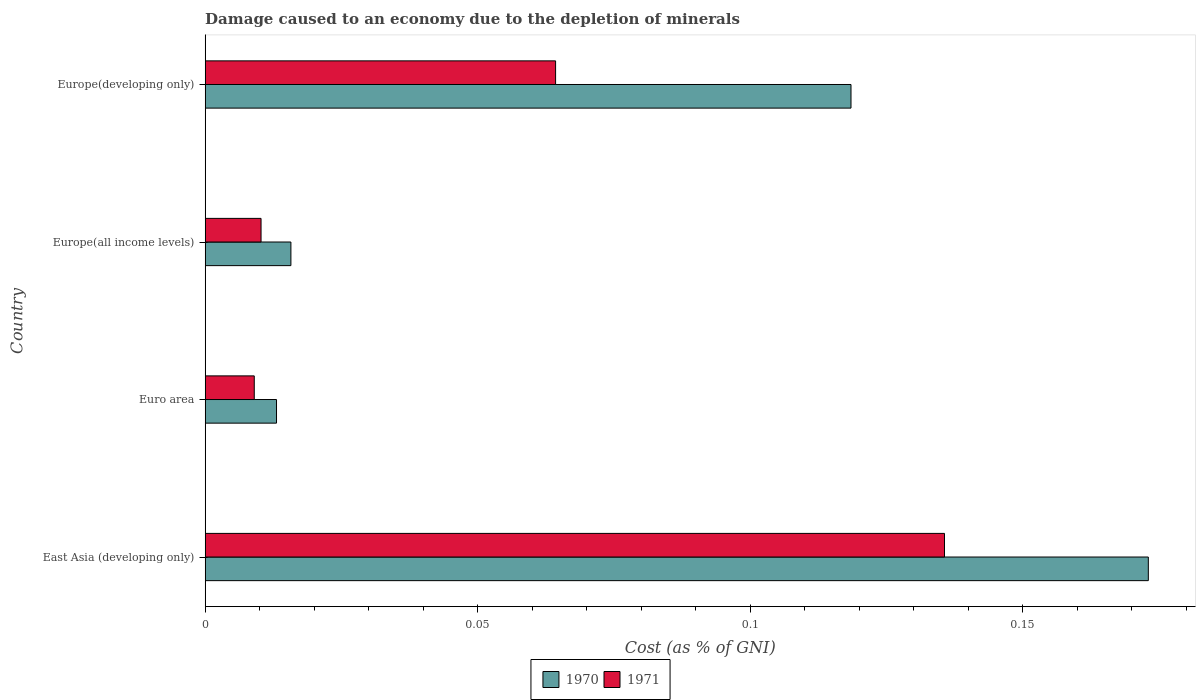How many different coloured bars are there?
Offer a very short reply. 2. How many groups of bars are there?
Offer a very short reply. 4. Are the number of bars per tick equal to the number of legend labels?
Keep it short and to the point. Yes. How many bars are there on the 2nd tick from the bottom?
Your answer should be compact. 2. What is the label of the 4th group of bars from the top?
Provide a short and direct response. East Asia (developing only). In how many cases, is the number of bars for a given country not equal to the number of legend labels?
Your answer should be very brief. 0. What is the cost of damage caused due to the depletion of minerals in 1971 in East Asia (developing only)?
Offer a very short reply. 0.14. Across all countries, what is the maximum cost of damage caused due to the depletion of minerals in 1971?
Keep it short and to the point. 0.14. Across all countries, what is the minimum cost of damage caused due to the depletion of minerals in 1971?
Provide a succinct answer. 0.01. In which country was the cost of damage caused due to the depletion of minerals in 1970 maximum?
Make the answer very short. East Asia (developing only). What is the total cost of damage caused due to the depletion of minerals in 1970 in the graph?
Keep it short and to the point. 0.32. What is the difference between the cost of damage caused due to the depletion of minerals in 1970 in Euro area and that in Europe(developing only)?
Make the answer very short. -0.11. What is the difference between the cost of damage caused due to the depletion of minerals in 1970 in East Asia (developing only) and the cost of damage caused due to the depletion of minerals in 1971 in Europe(all income levels)?
Provide a short and direct response. 0.16. What is the average cost of damage caused due to the depletion of minerals in 1971 per country?
Your answer should be compact. 0.05. What is the difference between the cost of damage caused due to the depletion of minerals in 1970 and cost of damage caused due to the depletion of minerals in 1971 in Euro area?
Your answer should be very brief. 0. In how many countries, is the cost of damage caused due to the depletion of minerals in 1971 greater than 0.16000000000000003 %?
Provide a succinct answer. 0. What is the ratio of the cost of damage caused due to the depletion of minerals in 1971 in East Asia (developing only) to that in Europe(all income levels)?
Give a very brief answer. 13.24. Is the cost of damage caused due to the depletion of minerals in 1971 in Europe(all income levels) less than that in Europe(developing only)?
Keep it short and to the point. Yes. What is the difference between the highest and the second highest cost of damage caused due to the depletion of minerals in 1970?
Ensure brevity in your answer.  0.05. What is the difference between the highest and the lowest cost of damage caused due to the depletion of minerals in 1971?
Provide a short and direct response. 0.13. In how many countries, is the cost of damage caused due to the depletion of minerals in 1970 greater than the average cost of damage caused due to the depletion of minerals in 1970 taken over all countries?
Give a very brief answer. 2. What does the 1st bar from the top in Euro area represents?
Provide a short and direct response. 1971. What does the 2nd bar from the bottom in East Asia (developing only) represents?
Offer a terse response. 1971. How many bars are there?
Ensure brevity in your answer.  8. Are all the bars in the graph horizontal?
Keep it short and to the point. Yes. Does the graph contain grids?
Provide a short and direct response. No. Where does the legend appear in the graph?
Your answer should be very brief. Bottom center. What is the title of the graph?
Keep it short and to the point. Damage caused to an economy due to the depletion of minerals. Does "2005" appear as one of the legend labels in the graph?
Offer a terse response. No. What is the label or title of the X-axis?
Offer a very short reply. Cost (as % of GNI). What is the label or title of the Y-axis?
Offer a very short reply. Country. What is the Cost (as % of GNI) in 1970 in East Asia (developing only)?
Your answer should be very brief. 0.17. What is the Cost (as % of GNI) of 1971 in East Asia (developing only)?
Keep it short and to the point. 0.14. What is the Cost (as % of GNI) of 1970 in Euro area?
Provide a succinct answer. 0.01. What is the Cost (as % of GNI) in 1971 in Euro area?
Provide a succinct answer. 0.01. What is the Cost (as % of GNI) of 1970 in Europe(all income levels)?
Your answer should be compact. 0.02. What is the Cost (as % of GNI) of 1971 in Europe(all income levels)?
Provide a succinct answer. 0.01. What is the Cost (as % of GNI) of 1970 in Europe(developing only)?
Your answer should be compact. 0.12. What is the Cost (as % of GNI) in 1971 in Europe(developing only)?
Make the answer very short. 0.06. Across all countries, what is the maximum Cost (as % of GNI) in 1970?
Provide a short and direct response. 0.17. Across all countries, what is the maximum Cost (as % of GNI) of 1971?
Make the answer very short. 0.14. Across all countries, what is the minimum Cost (as % of GNI) of 1970?
Your answer should be compact. 0.01. Across all countries, what is the minimum Cost (as % of GNI) in 1971?
Your answer should be very brief. 0.01. What is the total Cost (as % of GNI) of 1970 in the graph?
Provide a short and direct response. 0.32. What is the total Cost (as % of GNI) in 1971 in the graph?
Offer a terse response. 0.22. What is the difference between the Cost (as % of GNI) in 1970 in East Asia (developing only) and that in Euro area?
Offer a very short reply. 0.16. What is the difference between the Cost (as % of GNI) in 1971 in East Asia (developing only) and that in Euro area?
Make the answer very short. 0.13. What is the difference between the Cost (as % of GNI) of 1970 in East Asia (developing only) and that in Europe(all income levels)?
Make the answer very short. 0.16. What is the difference between the Cost (as % of GNI) of 1971 in East Asia (developing only) and that in Europe(all income levels)?
Provide a short and direct response. 0.13. What is the difference between the Cost (as % of GNI) in 1970 in East Asia (developing only) and that in Europe(developing only)?
Ensure brevity in your answer.  0.05. What is the difference between the Cost (as % of GNI) in 1971 in East Asia (developing only) and that in Europe(developing only)?
Your answer should be very brief. 0.07. What is the difference between the Cost (as % of GNI) of 1970 in Euro area and that in Europe(all income levels)?
Give a very brief answer. -0. What is the difference between the Cost (as % of GNI) in 1971 in Euro area and that in Europe(all income levels)?
Ensure brevity in your answer.  -0. What is the difference between the Cost (as % of GNI) of 1970 in Euro area and that in Europe(developing only)?
Make the answer very short. -0.11. What is the difference between the Cost (as % of GNI) in 1971 in Euro area and that in Europe(developing only)?
Give a very brief answer. -0.06. What is the difference between the Cost (as % of GNI) of 1970 in Europe(all income levels) and that in Europe(developing only)?
Make the answer very short. -0.1. What is the difference between the Cost (as % of GNI) of 1971 in Europe(all income levels) and that in Europe(developing only)?
Ensure brevity in your answer.  -0.05. What is the difference between the Cost (as % of GNI) in 1970 in East Asia (developing only) and the Cost (as % of GNI) in 1971 in Euro area?
Your answer should be compact. 0.16. What is the difference between the Cost (as % of GNI) of 1970 in East Asia (developing only) and the Cost (as % of GNI) of 1971 in Europe(all income levels)?
Give a very brief answer. 0.16. What is the difference between the Cost (as % of GNI) of 1970 in East Asia (developing only) and the Cost (as % of GNI) of 1971 in Europe(developing only)?
Provide a short and direct response. 0.11. What is the difference between the Cost (as % of GNI) of 1970 in Euro area and the Cost (as % of GNI) of 1971 in Europe(all income levels)?
Provide a succinct answer. 0. What is the difference between the Cost (as % of GNI) in 1970 in Euro area and the Cost (as % of GNI) in 1971 in Europe(developing only)?
Offer a very short reply. -0.05. What is the difference between the Cost (as % of GNI) in 1970 in Europe(all income levels) and the Cost (as % of GNI) in 1971 in Europe(developing only)?
Make the answer very short. -0.05. What is the average Cost (as % of GNI) of 1970 per country?
Your answer should be very brief. 0.08. What is the average Cost (as % of GNI) in 1971 per country?
Offer a terse response. 0.05. What is the difference between the Cost (as % of GNI) of 1970 and Cost (as % of GNI) of 1971 in East Asia (developing only)?
Provide a short and direct response. 0.04. What is the difference between the Cost (as % of GNI) of 1970 and Cost (as % of GNI) of 1971 in Euro area?
Offer a very short reply. 0. What is the difference between the Cost (as % of GNI) of 1970 and Cost (as % of GNI) of 1971 in Europe(all income levels)?
Ensure brevity in your answer.  0.01. What is the difference between the Cost (as % of GNI) in 1970 and Cost (as % of GNI) in 1971 in Europe(developing only)?
Provide a short and direct response. 0.05. What is the ratio of the Cost (as % of GNI) in 1970 in East Asia (developing only) to that in Euro area?
Provide a short and direct response. 13.22. What is the ratio of the Cost (as % of GNI) in 1971 in East Asia (developing only) to that in Euro area?
Your answer should be compact. 15.07. What is the ratio of the Cost (as % of GNI) of 1970 in East Asia (developing only) to that in Europe(all income levels)?
Your response must be concise. 11. What is the ratio of the Cost (as % of GNI) of 1971 in East Asia (developing only) to that in Europe(all income levels)?
Your answer should be compact. 13.24. What is the ratio of the Cost (as % of GNI) in 1970 in East Asia (developing only) to that in Europe(developing only)?
Make the answer very short. 1.46. What is the ratio of the Cost (as % of GNI) of 1971 in East Asia (developing only) to that in Europe(developing only)?
Give a very brief answer. 2.11. What is the ratio of the Cost (as % of GNI) in 1970 in Euro area to that in Europe(all income levels)?
Your answer should be very brief. 0.83. What is the ratio of the Cost (as % of GNI) of 1971 in Euro area to that in Europe(all income levels)?
Offer a terse response. 0.88. What is the ratio of the Cost (as % of GNI) in 1970 in Euro area to that in Europe(developing only)?
Offer a terse response. 0.11. What is the ratio of the Cost (as % of GNI) of 1971 in Euro area to that in Europe(developing only)?
Make the answer very short. 0.14. What is the ratio of the Cost (as % of GNI) of 1970 in Europe(all income levels) to that in Europe(developing only)?
Make the answer very short. 0.13. What is the ratio of the Cost (as % of GNI) in 1971 in Europe(all income levels) to that in Europe(developing only)?
Give a very brief answer. 0.16. What is the difference between the highest and the second highest Cost (as % of GNI) of 1970?
Your answer should be very brief. 0.05. What is the difference between the highest and the second highest Cost (as % of GNI) in 1971?
Keep it short and to the point. 0.07. What is the difference between the highest and the lowest Cost (as % of GNI) in 1970?
Offer a very short reply. 0.16. What is the difference between the highest and the lowest Cost (as % of GNI) of 1971?
Offer a very short reply. 0.13. 